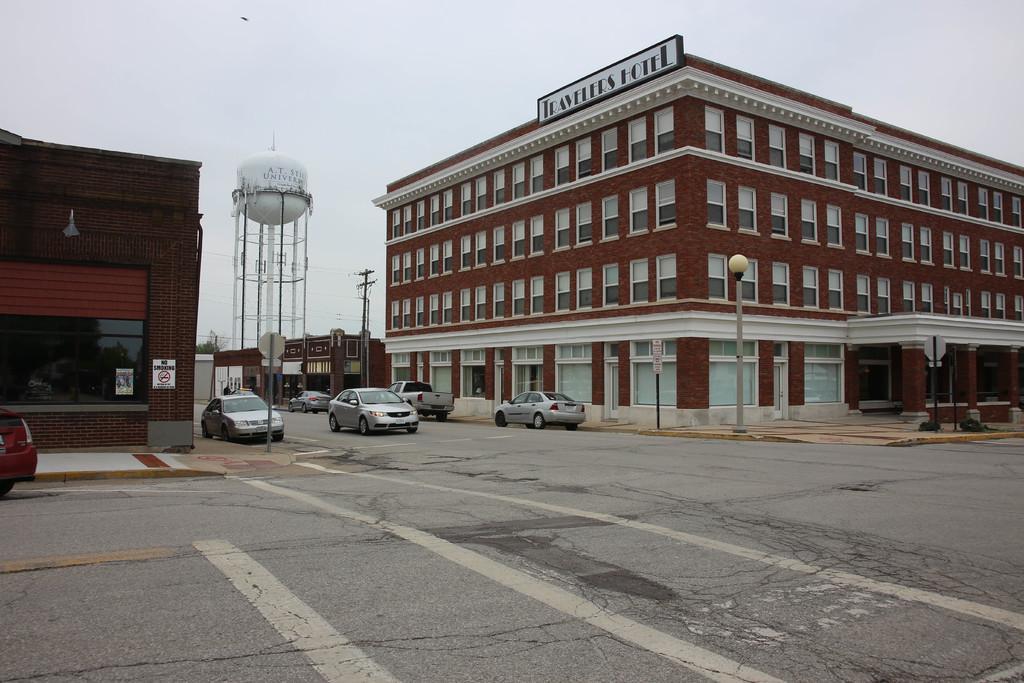How would you summarize this image in a sentence or two? At the bottom we can see vehicles on the road. In the background there are buildings, windows, poles, electric poles, sign board pole, trees, name board on the wall and sky. 